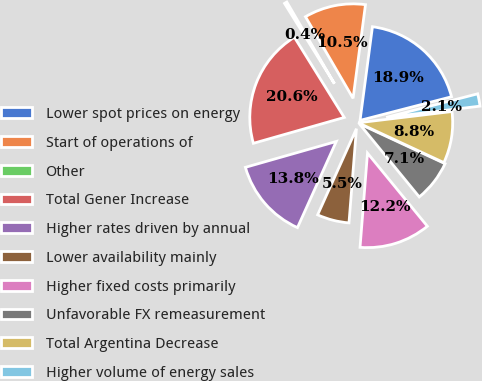Convert chart. <chart><loc_0><loc_0><loc_500><loc_500><pie_chart><fcel>Lower spot prices on energy<fcel>Start of operations of<fcel>Other<fcel>Total Gener Increase<fcel>Higher rates driven by annual<fcel>Lower availability mainly<fcel>Higher fixed costs primarily<fcel>Unfavorable FX remeasurement<fcel>Total Argentina Decrease<fcel>Higher volume of energy sales<nl><fcel>18.88%<fcel>10.5%<fcel>0.45%<fcel>20.56%<fcel>13.85%<fcel>5.48%<fcel>12.18%<fcel>7.15%<fcel>8.83%<fcel>2.12%<nl></chart> 